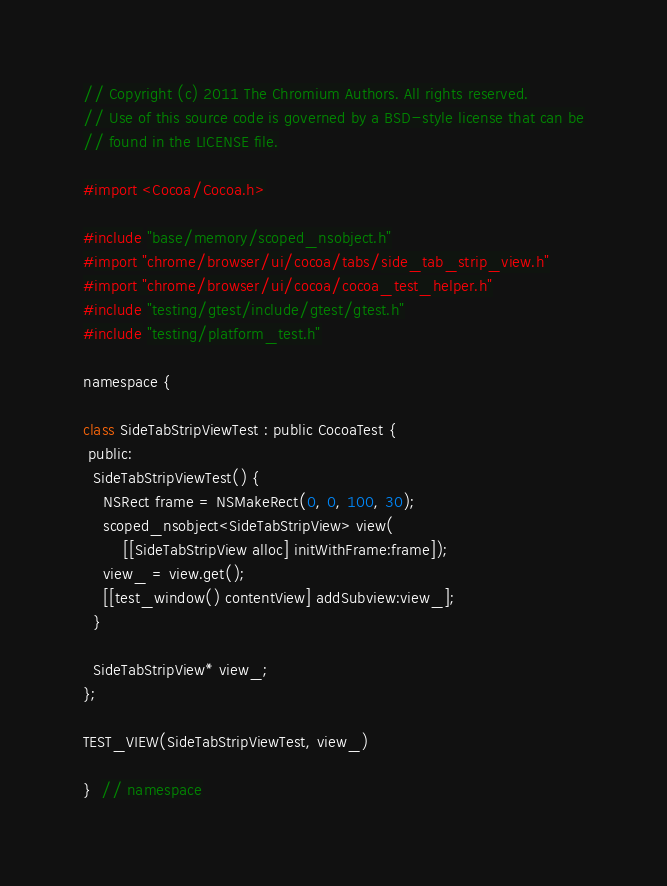Convert code to text. <code><loc_0><loc_0><loc_500><loc_500><_ObjectiveC_>// Copyright (c) 2011 The Chromium Authors. All rights reserved.
// Use of this source code is governed by a BSD-style license that can be
// found in the LICENSE file.

#import <Cocoa/Cocoa.h>

#include "base/memory/scoped_nsobject.h"
#import "chrome/browser/ui/cocoa/tabs/side_tab_strip_view.h"
#import "chrome/browser/ui/cocoa/cocoa_test_helper.h"
#include "testing/gtest/include/gtest/gtest.h"
#include "testing/platform_test.h"

namespace {

class SideTabStripViewTest : public CocoaTest {
 public:
  SideTabStripViewTest() {
    NSRect frame = NSMakeRect(0, 0, 100, 30);
    scoped_nsobject<SideTabStripView> view(
        [[SideTabStripView alloc] initWithFrame:frame]);
    view_ = view.get();
    [[test_window() contentView] addSubview:view_];
  }

  SideTabStripView* view_;
};

TEST_VIEW(SideTabStripViewTest, view_)

}  // namespace
</code> 